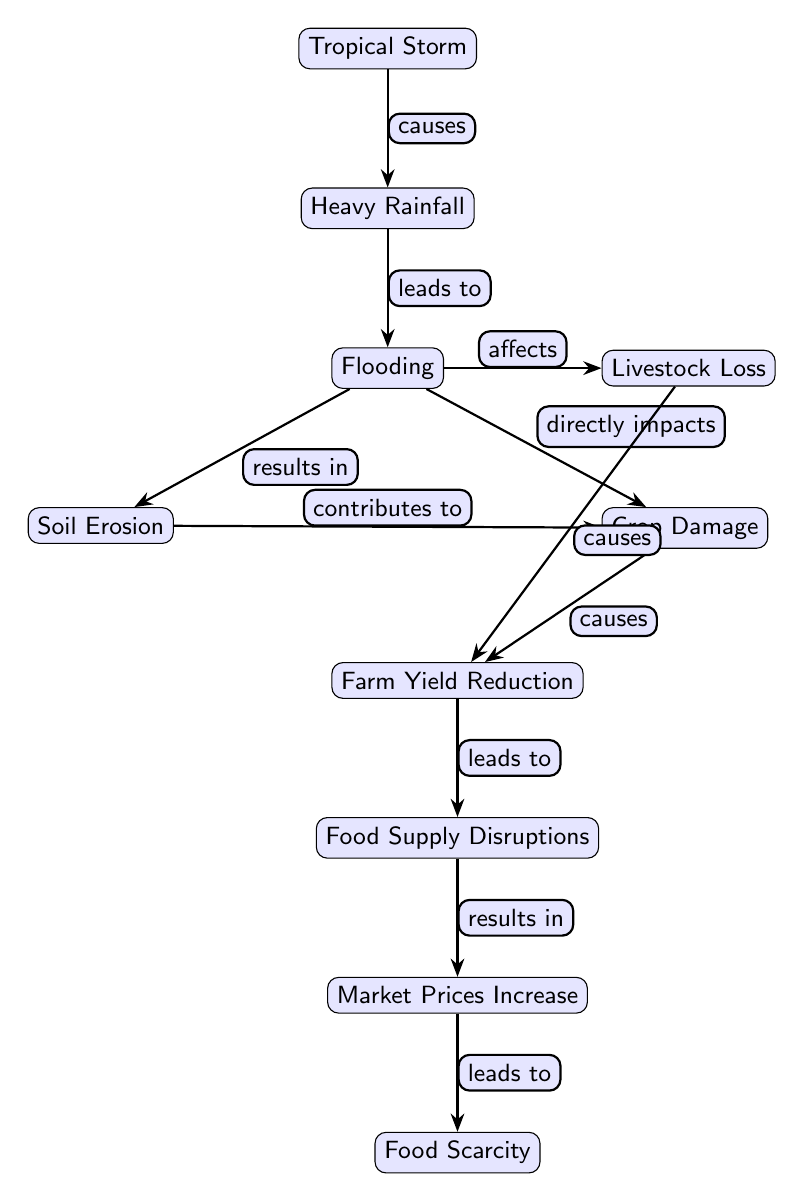What is the first node in the diagram? The first node in the diagram is labeled "Tropical Storm." It is the starting point, representing the initial event that initiates the food chain process depicted here.
Answer: Tropical Storm How many nodes are depicted in the diagram? To find the number of nodes, we can count each distinct label in the diagram. There are ten nodes listed, from "Tropical Storm" to "Food Scarcity."
Answer: 10 What effect does Heavy Rainfall have in the flow of the diagram? Heavy Rainfall leads to Flooding, indicating that it is a direct cause that results in the subsequent condition represented by the next node.
Answer: Flooding What are the two direct results of Flooding in the diagram? Flooding directly impacts Crop Damage and also affects Livestock Loss. These two nodes show how flooding causes damage to both crops and livestock.
Answer: Crop Damage, Livestock Loss Which node results from both Soil Erosion and Crop Damage? Farm Yield Reduction is the result that comes from both Soil Erosion and Crop Damage. This indicates that both negative factors contribute to reducing farm yields.
Answer: Farm Yield Reduction What progression leads from Farm Yield Reduction to Food Scarcity? Farm Yield Reduction leads to Food Supply Disruptions, which then results in Market Prices Increase, and ultimately leads to Food Scarcity. This flow of events signifies the cascading effects of agricultural yield reduction on food availability.
Answer: Food Scarcity Which two nodes contribute to Farm Yield Reduction? The two nodes contributing to Farm Yield Reduction are Crop Damage (due to flooding) and Soil Erosion (resulting from flooding). Both conditions adversely affect farm outputs leading to reduced yields.
Answer: Crop Damage, Soil Erosion What is the final outcome in the diagram? The final outcome is "Food Scarcity," which represents the end point of the food chain affected by the preceding events and conditions related to tropical storms and their impact on agriculture.
Answer: Food Scarcity How does Flooding affect the livestock in the food chain? Flooding affects livestock by causing Livestock Loss, indicating that the damages from flooding extend beyond crops to include livestock as well. This demonstrated interconnection shows that agricultural disruptions impact multiple aspects of food production.
Answer: Livestock Loss 